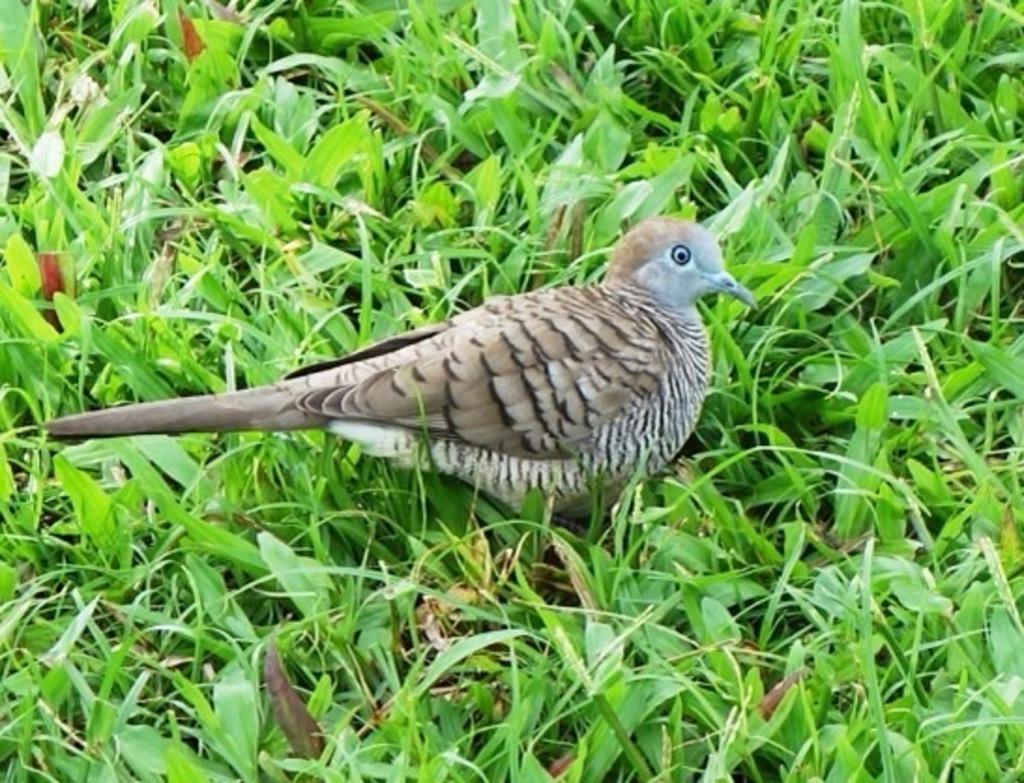What is the main feature in the center of the image? There is grass in the center of the image. What can be seen on the grass? There is a bird on the grass. What colors are visible on the bird? The bird is in ash and white color. What type of sack is being used by the bird in the image? There is no sack present in the image; it features a bird on grass. What language is the bird speaking in the image? Birds do not speak human languages, and there is no indication of any language being spoken in the image. 